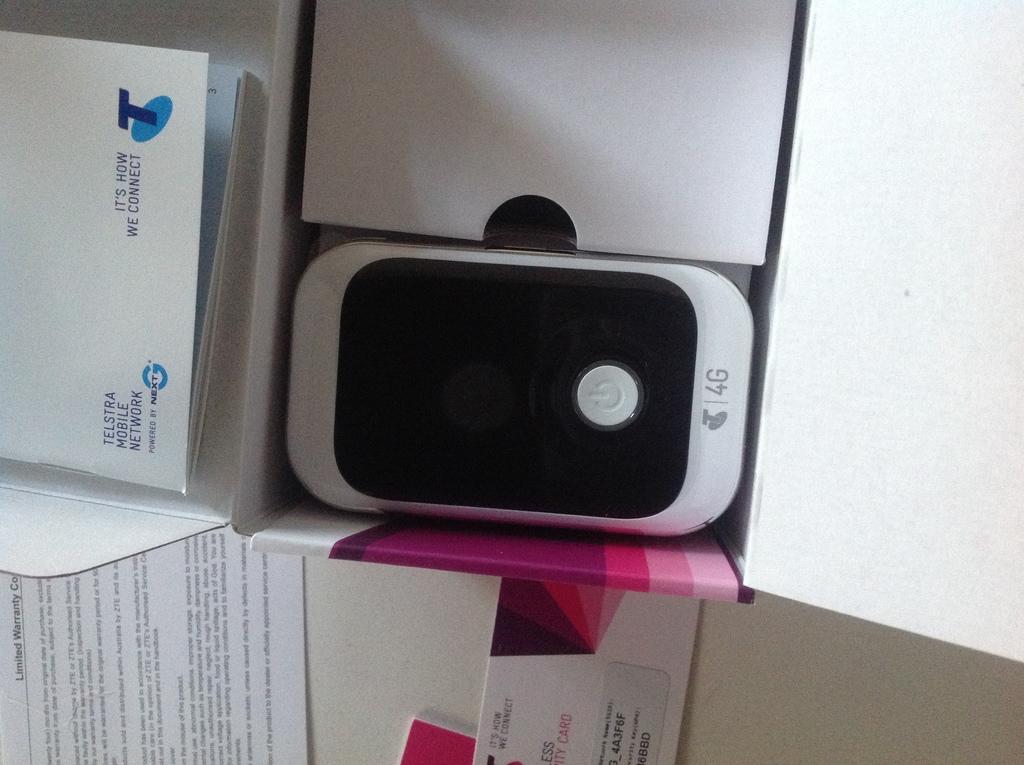What mobile network supports this phone?
Your answer should be compact. 4g. What is the brand name of the phone?
Your answer should be compact. Telstra. 